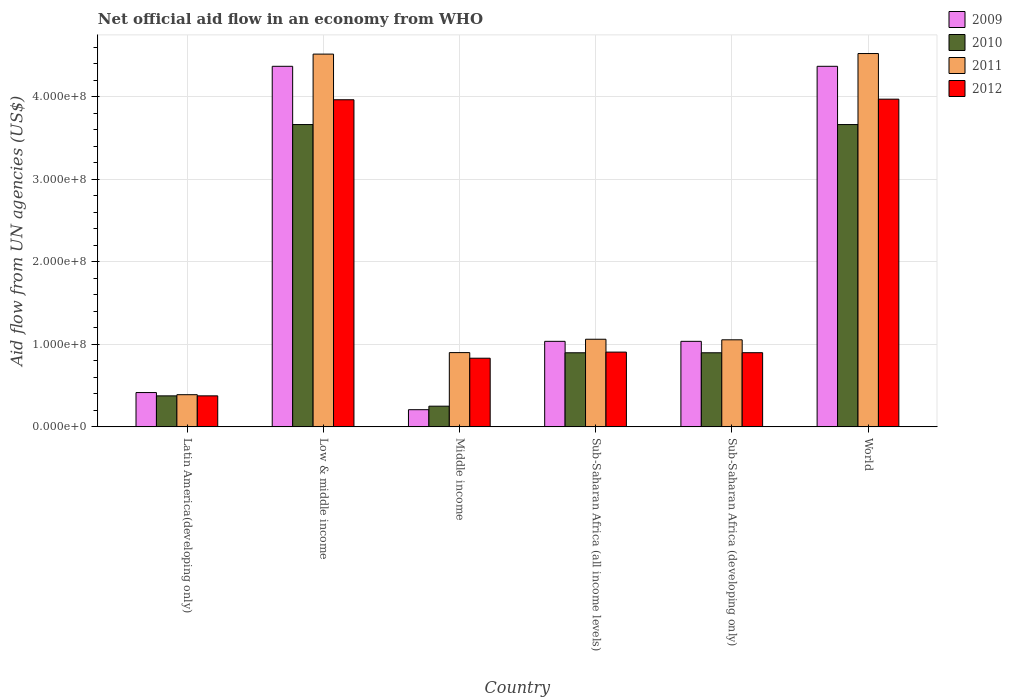Are the number of bars on each tick of the X-axis equal?
Your response must be concise. Yes. How many bars are there on the 5th tick from the left?
Keep it short and to the point. 4. What is the label of the 1st group of bars from the left?
Provide a succinct answer. Latin America(developing only). In how many cases, is the number of bars for a given country not equal to the number of legend labels?
Offer a terse response. 0. What is the net official aid flow in 2010 in Sub-Saharan Africa (all income levels)?
Your answer should be compact. 8.98e+07. Across all countries, what is the maximum net official aid flow in 2012?
Make the answer very short. 3.97e+08. Across all countries, what is the minimum net official aid flow in 2010?
Offer a terse response. 2.51e+07. In which country was the net official aid flow in 2012 minimum?
Your answer should be compact. Latin America(developing only). What is the total net official aid flow in 2009 in the graph?
Provide a short and direct response. 1.14e+09. What is the difference between the net official aid flow in 2009 in Latin America(developing only) and that in Middle income?
Provide a succinct answer. 2.08e+07. What is the difference between the net official aid flow in 2012 in Low & middle income and the net official aid flow in 2010 in World?
Give a very brief answer. 3.00e+07. What is the average net official aid flow in 2010 per country?
Offer a very short reply. 1.62e+08. What is the difference between the net official aid flow of/in 2011 and net official aid flow of/in 2012 in Middle income?
Provide a short and direct response. 6.80e+06. In how many countries, is the net official aid flow in 2011 greater than 400000000 US$?
Offer a very short reply. 2. What is the ratio of the net official aid flow in 2012 in Latin America(developing only) to that in Sub-Saharan Africa (all income levels)?
Provide a succinct answer. 0.41. Is the net official aid flow in 2009 in Sub-Saharan Africa (developing only) less than that in World?
Make the answer very short. Yes. Is the difference between the net official aid flow in 2011 in Sub-Saharan Africa (all income levels) and World greater than the difference between the net official aid flow in 2012 in Sub-Saharan Africa (all income levels) and World?
Your answer should be compact. No. What is the difference between the highest and the second highest net official aid flow in 2012?
Make the answer very short. 3.06e+08. What is the difference between the highest and the lowest net official aid flow in 2010?
Ensure brevity in your answer.  3.41e+08. In how many countries, is the net official aid flow in 2012 greater than the average net official aid flow in 2012 taken over all countries?
Keep it short and to the point. 2. Is it the case that in every country, the sum of the net official aid flow in 2010 and net official aid flow in 2009 is greater than the sum of net official aid flow in 2011 and net official aid flow in 2012?
Your answer should be compact. No. Is it the case that in every country, the sum of the net official aid flow in 2011 and net official aid flow in 2012 is greater than the net official aid flow in 2009?
Offer a terse response. Yes. How many bars are there?
Provide a succinct answer. 24. Are all the bars in the graph horizontal?
Offer a very short reply. No. How many countries are there in the graph?
Provide a succinct answer. 6. Does the graph contain grids?
Give a very brief answer. Yes. How many legend labels are there?
Your answer should be compact. 4. What is the title of the graph?
Keep it short and to the point. Net official aid flow in an economy from WHO. Does "1974" appear as one of the legend labels in the graph?
Your answer should be very brief. No. What is the label or title of the Y-axis?
Make the answer very short. Aid flow from UN agencies (US$). What is the Aid flow from UN agencies (US$) in 2009 in Latin America(developing only)?
Make the answer very short. 4.16e+07. What is the Aid flow from UN agencies (US$) in 2010 in Latin America(developing only)?
Offer a terse response. 3.76e+07. What is the Aid flow from UN agencies (US$) of 2011 in Latin America(developing only)?
Offer a terse response. 3.90e+07. What is the Aid flow from UN agencies (US$) of 2012 in Latin America(developing only)?
Offer a very short reply. 3.76e+07. What is the Aid flow from UN agencies (US$) in 2009 in Low & middle income?
Your response must be concise. 4.37e+08. What is the Aid flow from UN agencies (US$) in 2010 in Low & middle income?
Ensure brevity in your answer.  3.66e+08. What is the Aid flow from UN agencies (US$) of 2011 in Low & middle income?
Offer a terse response. 4.52e+08. What is the Aid flow from UN agencies (US$) of 2012 in Low & middle income?
Offer a very short reply. 3.96e+08. What is the Aid flow from UN agencies (US$) in 2009 in Middle income?
Make the answer very short. 2.08e+07. What is the Aid flow from UN agencies (US$) of 2010 in Middle income?
Keep it short and to the point. 2.51e+07. What is the Aid flow from UN agencies (US$) of 2011 in Middle income?
Your answer should be very brief. 9.00e+07. What is the Aid flow from UN agencies (US$) of 2012 in Middle income?
Provide a short and direct response. 8.32e+07. What is the Aid flow from UN agencies (US$) of 2009 in Sub-Saharan Africa (all income levels)?
Offer a terse response. 1.04e+08. What is the Aid flow from UN agencies (US$) of 2010 in Sub-Saharan Africa (all income levels)?
Your answer should be compact. 8.98e+07. What is the Aid flow from UN agencies (US$) in 2011 in Sub-Saharan Africa (all income levels)?
Give a very brief answer. 1.06e+08. What is the Aid flow from UN agencies (US$) of 2012 in Sub-Saharan Africa (all income levels)?
Provide a succinct answer. 9.06e+07. What is the Aid flow from UN agencies (US$) in 2009 in Sub-Saharan Africa (developing only)?
Your response must be concise. 1.04e+08. What is the Aid flow from UN agencies (US$) of 2010 in Sub-Saharan Africa (developing only)?
Ensure brevity in your answer.  8.98e+07. What is the Aid flow from UN agencies (US$) in 2011 in Sub-Saharan Africa (developing only)?
Your answer should be compact. 1.05e+08. What is the Aid flow from UN agencies (US$) of 2012 in Sub-Saharan Africa (developing only)?
Your answer should be compact. 8.98e+07. What is the Aid flow from UN agencies (US$) of 2009 in World?
Offer a terse response. 4.37e+08. What is the Aid flow from UN agencies (US$) of 2010 in World?
Offer a terse response. 3.66e+08. What is the Aid flow from UN agencies (US$) in 2011 in World?
Your answer should be compact. 4.52e+08. What is the Aid flow from UN agencies (US$) in 2012 in World?
Keep it short and to the point. 3.97e+08. Across all countries, what is the maximum Aid flow from UN agencies (US$) in 2009?
Make the answer very short. 4.37e+08. Across all countries, what is the maximum Aid flow from UN agencies (US$) in 2010?
Keep it short and to the point. 3.66e+08. Across all countries, what is the maximum Aid flow from UN agencies (US$) of 2011?
Give a very brief answer. 4.52e+08. Across all countries, what is the maximum Aid flow from UN agencies (US$) in 2012?
Make the answer very short. 3.97e+08. Across all countries, what is the minimum Aid flow from UN agencies (US$) in 2009?
Give a very brief answer. 2.08e+07. Across all countries, what is the minimum Aid flow from UN agencies (US$) of 2010?
Your answer should be very brief. 2.51e+07. Across all countries, what is the minimum Aid flow from UN agencies (US$) in 2011?
Your response must be concise. 3.90e+07. Across all countries, what is the minimum Aid flow from UN agencies (US$) in 2012?
Make the answer very short. 3.76e+07. What is the total Aid flow from UN agencies (US$) of 2009 in the graph?
Give a very brief answer. 1.14e+09. What is the total Aid flow from UN agencies (US$) of 2010 in the graph?
Make the answer very short. 9.75e+08. What is the total Aid flow from UN agencies (US$) of 2011 in the graph?
Your answer should be very brief. 1.24e+09. What is the total Aid flow from UN agencies (US$) in 2012 in the graph?
Provide a short and direct response. 1.09e+09. What is the difference between the Aid flow from UN agencies (US$) in 2009 in Latin America(developing only) and that in Low & middle income?
Provide a short and direct response. -3.95e+08. What is the difference between the Aid flow from UN agencies (US$) of 2010 in Latin America(developing only) and that in Low & middle income?
Your response must be concise. -3.29e+08. What is the difference between the Aid flow from UN agencies (US$) of 2011 in Latin America(developing only) and that in Low & middle income?
Ensure brevity in your answer.  -4.13e+08. What is the difference between the Aid flow from UN agencies (US$) in 2012 in Latin America(developing only) and that in Low & middle income?
Your response must be concise. -3.59e+08. What is the difference between the Aid flow from UN agencies (US$) of 2009 in Latin America(developing only) and that in Middle income?
Give a very brief answer. 2.08e+07. What is the difference between the Aid flow from UN agencies (US$) of 2010 in Latin America(developing only) and that in Middle income?
Give a very brief answer. 1.25e+07. What is the difference between the Aid flow from UN agencies (US$) in 2011 in Latin America(developing only) and that in Middle income?
Your response must be concise. -5.10e+07. What is the difference between the Aid flow from UN agencies (US$) in 2012 in Latin America(developing only) and that in Middle income?
Keep it short and to the point. -4.56e+07. What is the difference between the Aid flow from UN agencies (US$) of 2009 in Latin America(developing only) and that in Sub-Saharan Africa (all income levels)?
Your answer should be very brief. -6.20e+07. What is the difference between the Aid flow from UN agencies (US$) of 2010 in Latin America(developing only) and that in Sub-Saharan Africa (all income levels)?
Provide a short and direct response. -5.22e+07. What is the difference between the Aid flow from UN agencies (US$) of 2011 in Latin America(developing only) and that in Sub-Saharan Africa (all income levels)?
Your response must be concise. -6.72e+07. What is the difference between the Aid flow from UN agencies (US$) of 2012 in Latin America(developing only) and that in Sub-Saharan Africa (all income levels)?
Offer a terse response. -5.30e+07. What is the difference between the Aid flow from UN agencies (US$) in 2009 in Latin America(developing only) and that in Sub-Saharan Africa (developing only)?
Give a very brief answer. -6.20e+07. What is the difference between the Aid flow from UN agencies (US$) in 2010 in Latin America(developing only) and that in Sub-Saharan Africa (developing only)?
Ensure brevity in your answer.  -5.22e+07. What is the difference between the Aid flow from UN agencies (US$) in 2011 in Latin America(developing only) and that in Sub-Saharan Africa (developing only)?
Your answer should be very brief. -6.65e+07. What is the difference between the Aid flow from UN agencies (US$) of 2012 in Latin America(developing only) and that in Sub-Saharan Africa (developing only)?
Keep it short and to the point. -5.23e+07. What is the difference between the Aid flow from UN agencies (US$) in 2009 in Latin America(developing only) and that in World?
Offer a terse response. -3.95e+08. What is the difference between the Aid flow from UN agencies (US$) of 2010 in Latin America(developing only) and that in World?
Offer a very short reply. -3.29e+08. What is the difference between the Aid flow from UN agencies (US$) of 2011 in Latin America(developing only) and that in World?
Your answer should be compact. -4.13e+08. What is the difference between the Aid flow from UN agencies (US$) in 2012 in Latin America(developing only) and that in World?
Offer a terse response. -3.59e+08. What is the difference between the Aid flow from UN agencies (US$) of 2009 in Low & middle income and that in Middle income?
Give a very brief answer. 4.16e+08. What is the difference between the Aid flow from UN agencies (US$) of 2010 in Low & middle income and that in Middle income?
Give a very brief answer. 3.41e+08. What is the difference between the Aid flow from UN agencies (US$) of 2011 in Low & middle income and that in Middle income?
Your response must be concise. 3.62e+08. What is the difference between the Aid flow from UN agencies (US$) of 2012 in Low & middle income and that in Middle income?
Your answer should be compact. 3.13e+08. What is the difference between the Aid flow from UN agencies (US$) of 2009 in Low & middle income and that in Sub-Saharan Africa (all income levels)?
Offer a very short reply. 3.33e+08. What is the difference between the Aid flow from UN agencies (US$) of 2010 in Low & middle income and that in Sub-Saharan Africa (all income levels)?
Your response must be concise. 2.76e+08. What is the difference between the Aid flow from UN agencies (US$) in 2011 in Low & middle income and that in Sub-Saharan Africa (all income levels)?
Provide a succinct answer. 3.45e+08. What is the difference between the Aid flow from UN agencies (US$) in 2012 in Low & middle income and that in Sub-Saharan Africa (all income levels)?
Your answer should be compact. 3.06e+08. What is the difference between the Aid flow from UN agencies (US$) in 2009 in Low & middle income and that in Sub-Saharan Africa (developing only)?
Give a very brief answer. 3.33e+08. What is the difference between the Aid flow from UN agencies (US$) of 2010 in Low & middle income and that in Sub-Saharan Africa (developing only)?
Offer a very short reply. 2.76e+08. What is the difference between the Aid flow from UN agencies (US$) in 2011 in Low & middle income and that in Sub-Saharan Africa (developing only)?
Ensure brevity in your answer.  3.46e+08. What is the difference between the Aid flow from UN agencies (US$) of 2012 in Low & middle income and that in Sub-Saharan Africa (developing only)?
Your answer should be compact. 3.06e+08. What is the difference between the Aid flow from UN agencies (US$) of 2009 in Low & middle income and that in World?
Offer a terse response. 0. What is the difference between the Aid flow from UN agencies (US$) in 2010 in Low & middle income and that in World?
Ensure brevity in your answer.  0. What is the difference between the Aid flow from UN agencies (US$) of 2011 in Low & middle income and that in World?
Give a very brief answer. -6.70e+05. What is the difference between the Aid flow from UN agencies (US$) of 2012 in Low & middle income and that in World?
Give a very brief answer. -7.20e+05. What is the difference between the Aid flow from UN agencies (US$) of 2009 in Middle income and that in Sub-Saharan Africa (all income levels)?
Your answer should be very brief. -8.28e+07. What is the difference between the Aid flow from UN agencies (US$) in 2010 in Middle income and that in Sub-Saharan Africa (all income levels)?
Give a very brief answer. -6.47e+07. What is the difference between the Aid flow from UN agencies (US$) of 2011 in Middle income and that in Sub-Saharan Africa (all income levels)?
Offer a very short reply. -1.62e+07. What is the difference between the Aid flow from UN agencies (US$) in 2012 in Middle income and that in Sub-Saharan Africa (all income levels)?
Make the answer very short. -7.39e+06. What is the difference between the Aid flow from UN agencies (US$) of 2009 in Middle income and that in Sub-Saharan Africa (developing only)?
Give a very brief answer. -8.28e+07. What is the difference between the Aid flow from UN agencies (US$) of 2010 in Middle income and that in Sub-Saharan Africa (developing only)?
Your answer should be very brief. -6.47e+07. What is the difference between the Aid flow from UN agencies (US$) in 2011 in Middle income and that in Sub-Saharan Africa (developing only)?
Provide a succinct answer. -1.55e+07. What is the difference between the Aid flow from UN agencies (US$) in 2012 in Middle income and that in Sub-Saharan Africa (developing only)?
Make the answer very short. -6.67e+06. What is the difference between the Aid flow from UN agencies (US$) in 2009 in Middle income and that in World?
Offer a very short reply. -4.16e+08. What is the difference between the Aid flow from UN agencies (US$) of 2010 in Middle income and that in World?
Your answer should be compact. -3.41e+08. What is the difference between the Aid flow from UN agencies (US$) of 2011 in Middle income and that in World?
Provide a short and direct response. -3.62e+08. What is the difference between the Aid flow from UN agencies (US$) of 2012 in Middle income and that in World?
Give a very brief answer. -3.14e+08. What is the difference between the Aid flow from UN agencies (US$) of 2009 in Sub-Saharan Africa (all income levels) and that in Sub-Saharan Africa (developing only)?
Keep it short and to the point. 0. What is the difference between the Aid flow from UN agencies (US$) in 2010 in Sub-Saharan Africa (all income levels) and that in Sub-Saharan Africa (developing only)?
Make the answer very short. 0. What is the difference between the Aid flow from UN agencies (US$) in 2011 in Sub-Saharan Africa (all income levels) and that in Sub-Saharan Africa (developing only)?
Give a very brief answer. 6.70e+05. What is the difference between the Aid flow from UN agencies (US$) in 2012 in Sub-Saharan Africa (all income levels) and that in Sub-Saharan Africa (developing only)?
Offer a very short reply. 7.20e+05. What is the difference between the Aid flow from UN agencies (US$) in 2009 in Sub-Saharan Africa (all income levels) and that in World?
Provide a short and direct response. -3.33e+08. What is the difference between the Aid flow from UN agencies (US$) of 2010 in Sub-Saharan Africa (all income levels) and that in World?
Your response must be concise. -2.76e+08. What is the difference between the Aid flow from UN agencies (US$) of 2011 in Sub-Saharan Africa (all income levels) and that in World?
Ensure brevity in your answer.  -3.46e+08. What is the difference between the Aid flow from UN agencies (US$) in 2012 in Sub-Saharan Africa (all income levels) and that in World?
Provide a succinct answer. -3.06e+08. What is the difference between the Aid flow from UN agencies (US$) of 2009 in Sub-Saharan Africa (developing only) and that in World?
Your answer should be compact. -3.33e+08. What is the difference between the Aid flow from UN agencies (US$) in 2010 in Sub-Saharan Africa (developing only) and that in World?
Ensure brevity in your answer.  -2.76e+08. What is the difference between the Aid flow from UN agencies (US$) in 2011 in Sub-Saharan Africa (developing only) and that in World?
Your answer should be very brief. -3.47e+08. What is the difference between the Aid flow from UN agencies (US$) in 2012 in Sub-Saharan Africa (developing only) and that in World?
Offer a very short reply. -3.07e+08. What is the difference between the Aid flow from UN agencies (US$) of 2009 in Latin America(developing only) and the Aid flow from UN agencies (US$) of 2010 in Low & middle income?
Provide a succinct answer. -3.25e+08. What is the difference between the Aid flow from UN agencies (US$) in 2009 in Latin America(developing only) and the Aid flow from UN agencies (US$) in 2011 in Low & middle income?
Ensure brevity in your answer.  -4.10e+08. What is the difference between the Aid flow from UN agencies (US$) in 2009 in Latin America(developing only) and the Aid flow from UN agencies (US$) in 2012 in Low & middle income?
Provide a succinct answer. -3.55e+08. What is the difference between the Aid flow from UN agencies (US$) of 2010 in Latin America(developing only) and the Aid flow from UN agencies (US$) of 2011 in Low & middle income?
Offer a terse response. -4.14e+08. What is the difference between the Aid flow from UN agencies (US$) in 2010 in Latin America(developing only) and the Aid flow from UN agencies (US$) in 2012 in Low & middle income?
Your answer should be compact. -3.59e+08. What is the difference between the Aid flow from UN agencies (US$) in 2011 in Latin America(developing only) and the Aid flow from UN agencies (US$) in 2012 in Low & middle income?
Your answer should be very brief. -3.57e+08. What is the difference between the Aid flow from UN agencies (US$) in 2009 in Latin America(developing only) and the Aid flow from UN agencies (US$) in 2010 in Middle income?
Give a very brief answer. 1.65e+07. What is the difference between the Aid flow from UN agencies (US$) in 2009 in Latin America(developing only) and the Aid flow from UN agencies (US$) in 2011 in Middle income?
Give a very brief answer. -4.84e+07. What is the difference between the Aid flow from UN agencies (US$) in 2009 in Latin America(developing only) and the Aid flow from UN agencies (US$) in 2012 in Middle income?
Make the answer very short. -4.16e+07. What is the difference between the Aid flow from UN agencies (US$) of 2010 in Latin America(developing only) and the Aid flow from UN agencies (US$) of 2011 in Middle income?
Your answer should be compact. -5.24e+07. What is the difference between the Aid flow from UN agencies (US$) of 2010 in Latin America(developing only) and the Aid flow from UN agencies (US$) of 2012 in Middle income?
Offer a very short reply. -4.56e+07. What is the difference between the Aid flow from UN agencies (US$) of 2011 in Latin America(developing only) and the Aid flow from UN agencies (US$) of 2012 in Middle income?
Your answer should be compact. -4.42e+07. What is the difference between the Aid flow from UN agencies (US$) in 2009 in Latin America(developing only) and the Aid flow from UN agencies (US$) in 2010 in Sub-Saharan Africa (all income levels)?
Keep it short and to the point. -4.82e+07. What is the difference between the Aid flow from UN agencies (US$) in 2009 in Latin America(developing only) and the Aid flow from UN agencies (US$) in 2011 in Sub-Saharan Africa (all income levels)?
Offer a very short reply. -6.46e+07. What is the difference between the Aid flow from UN agencies (US$) in 2009 in Latin America(developing only) and the Aid flow from UN agencies (US$) in 2012 in Sub-Saharan Africa (all income levels)?
Your response must be concise. -4.90e+07. What is the difference between the Aid flow from UN agencies (US$) in 2010 in Latin America(developing only) and the Aid flow from UN agencies (US$) in 2011 in Sub-Saharan Africa (all income levels)?
Your answer should be very brief. -6.86e+07. What is the difference between the Aid flow from UN agencies (US$) in 2010 in Latin America(developing only) and the Aid flow from UN agencies (US$) in 2012 in Sub-Saharan Africa (all income levels)?
Your response must be concise. -5.30e+07. What is the difference between the Aid flow from UN agencies (US$) of 2011 in Latin America(developing only) and the Aid flow from UN agencies (US$) of 2012 in Sub-Saharan Africa (all income levels)?
Your response must be concise. -5.16e+07. What is the difference between the Aid flow from UN agencies (US$) of 2009 in Latin America(developing only) and the Aid flow from UN agencies (US$) of 2010 in Sub-Saharan Africa (developing only)?
Provide a succinct answer. -4.82e+07. What is the difference between the Aid flow from UN agencies (US$) of 2009 in Latin America(developing only) and the Aid flow from UN agencies (US$) of 2011 in Sub-Saharan Africa (developing only)?
Ensure brevity in your answer.  -6.39e+07. What is the difference between the Aid flow from UN agencies (US$) of 2009 in Latin America(developing only) and the Aid flow from UN agencies (US$) of 2012 in Sub-Saharan Africa (developing only)?
Ensure brevity in your answer.  -4.83e+07. What is the difference between the Aid flow from UN agencies (US$) of 2010 in Latin America(developing only) and the Aid flow from UN agencies (US$) of 2011 in Sub-Saharan Africa (developing only)?
Your response must be concise. -6.79e+07. What is the difference between the Aid flow from UN agencies (US$) in 2010 in Latin America(developing only) and the Aid flow from UN agencies (US$) in 2012 in Sub-Saharan Africa (developing only)?
Your answer should be compact. -5.23e+07. What is the difference between the Aid flow from UN agencies (US$) in 2011 in Latin America(developing only) and the Aid flow from UN agencies (US$) in 2012 in Sub-Saharan Africa (developing only)?
Keep it short and to the point. -5.09e+07. What is the difference between the Aid flow from UN agencies (US$) of 2009 in Latin America(developing only) and the Aid flow from UN agencies (US$) of 2010 in World?
Give a very brief answer. -3.25e+08. What is the difference between the Aid flow from UN agencies (US$) in 2009 in Latin America(developing only) and the Aid flow from UN agencies (US$) in 2011 in World?
Make the answer very short. -4.11e+08. What is the difference between the Aid flow from UN agencies (US$) of 2009 in Latin America(developing only) and the Aid flow from UN agencies (US$) of 2012 in World?
Provide a short and direct response. -3.55e+08. What is the difference between the Aid flow from UN agencies (US$) of 2010 in Latin America(developing only) and the Aid flow from UN agencies (US$) of 2011 in World?
Ensure brevity in your answer.  -4.15e+08. What is the difference between the Aid flow from UN agencies (US$) in 2010 in Latin America(developing only) and the Aid flow from UN agencies (US$) in 2012 in World?
Provide a succinct answer. -3.59e+08. What is the difference between the Aid flow from UN agencies (US$) in 2011 in Latin America(developing only) and the Aid flow from UN agencies (US$) in 2012 in World?
Your response must be concise. -3.58e+08. What is the difference between the Aid flow from UN agencies (US$) of 2009 in Low & middle income and the Aid flow from UN agencies (US$) of 2010 in Middle income?
Provide a short and direct response. 4.12e+08. What is the difference between the Aid flow from UN agencies (US$) in 2009 in Low & middle income and the Aid flow from UN agencies (US$) in 2011 in Middle income?
Make the answer very short. 3.47e+08. What is the difference between the Aid flow from UN agencies (US$) of 2009 in Low & middle income and the Aid flow from UN agencies (US$) of 2012 in Middle income?
Give a very brief answer. 3.54e+08. What is the difference between the Aid flow from UN agencies (US$) of 2010 in Low & middle income and the Aid flow from UN agencies (US$) of 2011 in Middle income?
Make the answer very short. 2.76e+08. What is the difference between the Aid flow from UN agencies (US$) of 2010 in Low & middle income and the Aid flow from UN agencies (US$) of 2012 in Middle income?
Your answer should be very brief. 2.83e+08. What is the difference between the Aid flow from UN agencies (US$) in 2011 in Low & middle income and the Aid flow from UN agencies (US$) in 2012 in Middle income?
Your response must be concise. 3.68e+08. What is the difference between the Aid flow from UN agencies (US$) in 2009 in Low & middle income and the Aid flow from UN agencies (US$) in 2010 in Sub-Saharan Africa (all income levels)?
Your answer should be very brief. 3.47e+08. What is the difference between the Aid flow from UN agencies (US$) in 2009 in Low & middle income and the Aid flow from UN agencies (US$) in 2011 in Sub-Saharan Africa (all income levels)?
Make the answer very short. 3.31e+08. What is the difference between the Aid flow from UN agencies (US$) of 2009 in Low & middle income and the Aid flow from UN agencies (US$) of 2012 in Sub-Saharan Africa (all income levels)?
Provide a succinct answer. 3.46e+08. What is the difference between the Aid flow from UN agencies (US$) of 2010 in Low & middle income and the Aid flow from UN agencies (US$) of 2011 in Sub-Saharan Africa (all income levels)?
Provide a short and direct response. 2.60e+08. What is the difference between the Aid flow from UN agencies (US$) in 2010 in Low & middle income and the Aid flow from UN agencies (US$) in 2012 in Sub-Saharan Africa (all income levels)?
Offer a terse response. 2.76e+08. What is the difference between the Aid flow from UN agencies (US$) of 2011 in Low & middle income and the Aid flow from UN agencies (US$) of 2012 in Sub-Saharan Africa (all income levels)?
Provide a succinct answer. 3.61e+08. What is the difference between the Aid flow from UN agencies (US$) in 2009 in Low & middle income and the Aid flow from UN agencies (US$) in 2010 in Sub-Saharan Africa (developing only)?
Keep it short and to the point. 3.47e+08. What is the difference between the Aid flow from UN agencies (US$) in 2009 in Low & middle income and the Aid flow from UN agencies (US$) in 2011 in Sub-Saharan Africa (developing only)?
Your response must be concise. 3.31e+08. What is the difference between the Aid flow from UN agencies (US$) in 2009 in Low & middle income and the Aid flow from UN agencies (US$) in 2012 in Sub-Saharan Africa (developing only)?
Give a very brief answer. 3.47e+08. What is the difference between the Aid flow from UN agencies (US$) in 2010 in Low & middle income and the Aid flow from UN agencies (US$) in 2011 in Sub-Saharan Africa (developing only)?
Your answer should be compact. 2.61e+08. What is the difference between the Aid flow from UN agencies (US$) in 2010 in Low & middle income and the Aid flow from UN agencies (US$) in 2012 in Sub-Saharan Africa (developing only)?
Your answer should be very brief. 2.76e+08. What is the difference between the Aid flow from UN agencies (US$) of 2011 in Low & middle income and the Aid flow from UN agencies (US$) of 2012 in Sub-Saharan Africa (developing only)?
Provide a short and direct response. 3.62e+08. What is the difference between the Aid flow from UN agencies (US$) of 2009 in Low & middle income and the Aid flow from UN agencies (US$) of 2010 in World?
Your answer should be compact. 7.06e+07. What is the difference between the Aid flow from UN agencies (US$) of 2009 in Low & middle income and the Aid flow from UN agencies (US$) of 2011 in World?
Ensure brevity in your answer.  -1.55e+07. What is the difference between the Aid flow from UN agencies (US$) of 2009 in Low & middle income and the Aid flow from UN agencies (US$) of 2012 in World?
Your answer should be very brief. 3.98e+07. What is the difference between the Aid flow from UN agencies (US$) in 2010 in Low & middle income and the Aid flow from UN agencies (US$) in 2011 in World?
Your answer should be compact. -8.60e+07. What is the difference between the Aid flow from UN agencies (US$) in 2010 in Low & middle income and the Aid flow from UN agencies (US$) in 2012 in World?
Offer a terse response. -3.08e+07. What is the difference between the Aid flow from UN agencies (US$) of 2011 in Low & middle income and the Aid flow from UN agencies (US$) of 2012 in World?
Provide a succinct answer. 5.46e+07. What is the difference between the Aid flow from UN agencies (US$) of 2009 in Middle income and the Aid flow from UN agencies (US$) of 2010 in Sub-Saharan Africa (all income levels)?
Provide a short and direct response. -6.90e+07. What is the difference between the Aid flow from UN agencies (US$) in 2009 in Middle income and the Aid flow from UN agencies (US$) in 2011 in Sub-Saharan Africa (all income levels)?
Make the answer very short. -8.54e+07. What is the difference between the Aid flow from UN agencies (US$) in 2009 in Middle income and the Aid flow from UN agencies (US$) in 2012 in Sub-Saharan Africa (all income levels)?
Provide a short and direct response. -6.98e+07. What is the difference between the Aid flow from UN agencies (US$) of 2010 in Middle income and the Aid flow from UN agencies (US$) of 2011 in Sub-Saharan Africa (all income levels)?
Provide a short and direct response. -8.11e+07. What is the difference between the Aid flow from UN agencies (US$) in 2010 in Middle income and the Aid flow from UN agencies (US$) in 2012 in Sub-Saharan Africa (all income levels)?
Provide a short and direct response. -6.55e+07. What is the difference between the Aid flow from UN agencies (US$) in 2011 in Middle income and the Aid flow from UN agencies (US$) in 2012 in Sub-Saharan Africa (all income levels)?
Offer a very short reply. -5.90e+05. What is the difference between the Aid flow from UN agencies (US$) in 2009 in Middle income and the Aid flow from UN agencies (US$) in 2010 in Sub-Saharan Africa (developing only)?
Make the answer very short. -6.90e+07. What is the difference between the Aid flow from UN agencies (US$) of 2009 in Middle income and the Aid flow from UN agencies (US$) of 2011 in Sub-Saharan Africa (developing only)?
Your response must be concise. -8.47e+07. What is the difference between the Aid flow from UN agencies (US$) of 2009 in Middle income and the Aid flow from UN agencies (US$) of 2012 in Sub-Saharan Africa (developing only)?
Offer a terse response. -6.90e+07. What is the difference between the Aid flow from UN agencies (US$) in 2010 in Middle income and the Aid flow from UN agencies (US$) in 2011 in Sub-Saharan Africa (developing only)?
Your answer should be very brief. -8.04e+07. What is the difference between the Aid flow from UN agencies (US$) in 2010 in Middle income and the Aid flow from UN agencies (US$) in 2012 in Sub-Saharan Africa (developing only)?
Your answer should be very brief. -6.48e+07. What is the difference between the Aid flow from UN agencies (US$) in 2011 in Middle income and the Aid flow from UN agencies (US$) in 2012 in Sub-Saharan Africa (developing only)?
Your response must be concise. 1.30e+05. What is the difference between the Aid flow from UN agencies (US$) in 2009 in Middle income and the Aid flow from UN agencies (US$) in 2010 in World?
Make the answer very short. -3.45e+08. What is the difference between the Aid flow from UN agencies (US$) of 2009 in Middle income and the Aid flow from UN agencies (US$) of 2011 in World?
Keep it short and to the point. -4.31e+08. What is the difference between the Aid flow from UN agencies (US$) of 2009 in Middle income and the Aid flow from UN agencies (US$) of 2012 in World?
Your response must be concise. -3.76e+08. What is the difference between the Aid flow from UN agencies (US$) of 2010 in Middle income and the Aid flow from UN agencies (US$) of 2011 in World?
Keep it short and to the point. -4.27e+08. What is the difference between the Aid flow from UN agencies (US$) in 2010 in Middle income and the Aid flow from UN agencies (US$) in 2012 in World?
Your answer should be compact. -3.72e+08. What is the difference between the Aid flow from UN agencies (US$) in 2011 in Middle income and the Aid flow from UN agencies (US$) in 2012 in World?
Make the answer very short. -3.07e+08. What is the difference between the Aid flow from UN agencies (US$) in 2009 in Sub-Saharan Africa (all income levels) and the Aid flow from UN agencies (US$) in 2010 in Sub-Saharan Africa (developing only)?
Provide a short and direct response. 1.39e+07. What is the difference between the Aid flow from UN agencies (US$) in 2009 in Sub-Saharan Africa (all income levels) and the Aid flow from UN agencies (US$) in 2011 in Sub-Saharan Africa (developing only)?
Ensure brevity in your answer.  -1.86e+06. What is the difference between the Aid flow from UN agencies (US$) of 2009 in Sub-Saharan Africa (all income levels) and the Aid flow from UN agencies (US$) of 2012 in Sub-Saharan Africa (developing only)?
Provide a short and direct response. 1.38e+07. What is the difference between the Aid flow from UN agencies (US$) in 2010 in Sub-Saharan Africa (all income levels) and the Aid flow from UN agencies (US$) in 2011 in Sub-Saharan Africa (developing only)?
Offer a very short reply. -1.57e+07. What is the difference between the Aid flow from UN agencies (US$) of 2011 in Sub-Saharan Africa (all income levels) and the Aid flow from UN agencies (US$) of 2012 in Sub-Saharan Africa (developing only)?
Provide a succinct answer. 1.63e+07. What is the difference between the Aid flow from UN agencies (US$) of 2009 in Sub-Saharan Africa (all income levels) and the Aid flow from UN agencies (US$) of 2010 in World?
Offer a very short reply. -2.63e+08. What is the difference between the Aid flow from UN agencies (US$) in 2009 in Sub-Saharan Africa (all income levels) and the Aid flow from UN agencies (US$) in 2011 in World?
Your answer should be very brief. -3.49e+08. What is the difference between the Aid flow from UN agencies (US$) in 2009 in Sub-Saharan Africa (all income levels) and the Aid flow from UN agencies (US$) in 2012 in World?
Your answer should be very brief. -2.93e+08. What is the difference between the Aid flow from UN agencies (US$) of 2010 in Sub-Saharan Africa (all income levels) and the Aid flow from UN agencies (US$) of 2011 in World?
Offer a terse response. -3.62e+08. What is the difference between the Aid flow from UN agencies (US$) in 2010 in Sub-Saharan Africa (all income levels) and the Aid flow from UN agencies (US$) in 2012 in World?
Ensure brevity in your answer.  -3.07e+08. What is the difference between the Aid flow from UN agencies (US$) in 2011 in Sub-Saharan Africa (all income levels) and the Aid flow from UN agencies (US$) in 2012 in World?
Give a very brief answer. -2.91e+08. What is the difference between the Aid flow from UN agencies (US$) of 2009 in Sub-Saharan Africa (developing only) and the Aid flow from UN agencies (US$) of 2010 in World?
Keep it short and to the point. -2.63e+08. What is the difference between the Aid flow from UN agencies (US$) of 2009 in Sub-Saharan Africa (developing only) and the Aid flow from UN agencies (US$) of 2011 in World?
Provide a succinct answer. -3.49e+08. What is the difference between the Aid flow from UN agencies (US$) of 2009 in Sub-Saharan Africa (developing only) and the Aid flow from UN agencies (US$) of 2012 in World?
Provide a succinct answer. -2.93e+08. What is the difference between the Aid flow from UN agencies (US$) in 2010 in Sub-Saharan Africa (developing only) and the Aid flow from UN agencies (US$) in 2011 in World?
Ensure brevity in your answer.  -3.62e+08. What is the difference between the Aid flow from UN agencies (US$) in 2010 in Sub-Saharan Africa (developing only) and the Aid flow from UN agencies (US$) in 2012 in World?
Make the answer very short. -3.07e+08. What is the difference between the Aid flow from UN agencies (US$) of 2011 in Sub-Saharan Africa (developing only) and the Aid flow from UN agencies (US$) of 2012 in World?
Make the answer very short. -2.92e+08. What is the average Aid flow from UN agencies (US$) of 2009 per country?
Your answer should be very brief. 1.91e+08. What is the average Aid flow from UN agencies (US$) of 2010 per country?
Make the answer very short. 1.62e+08. What is the average Aid flow from UN agencies (US$) in 2011 per country?
Provide a succinct answer. 2.07e+08. What is the average Aid flow from UN agencies (US$) in 2012 per country?
Keep it short and to the point. 1.82e+08. What is the difference between the Aid flow from UN agencies (US$) of 2009 and Aid flow from UN agencies (US$) of 2010 in Latin America(developing only)?
Ensure brevity in your answer.  4.01e+06. What is the difference between the Aid flow from UN agencies (US$) of 2009 and Aid flow from UN agencies (US$) of 2011 in Latin America(developing only)?
Give a very brief answer. 2.59e+06. What is the difference between the Aid flow from UN agencies (US$) of 2009 and Aid flow from UN agencies (US$) of 2012 in Latin America(developing only)?
Make the answer very short. 3.99e+06. What is the difference between the Aid flow from UN agencies (US$) of 2010 and Aid flow from UN agencies (US$) of 2011 in Latin America(developing only)?
Keep it short and to the point. -1.42e+06. What is the difference between the Aid flow from UN agencies (US$) of 2010 and Aid flow from UN agencies (US$) of 2012 in Latin America(developing only)?
Keep it short and to the point. -2.00e+04. What is the difference between the Aid flow from UN agencies (US$) of 2011 and Aid flow from UN agencies (US$) of 2012 in Latin America(developing only)?
Keep it short and to the point. 1.40e+06. What is the difference between the Aid flow from UN agencies (US$) in 2009 and Aid flow from UN agencies (US$) in 2010 in Low & middle income?
Ensure brevity in your answer.  7.06e+07. What is the difference between the Aid flow from UN agencies (US$) of 2009 and Aid flow from UN agencies (US$) of 2011 in Low & middle income?
Your answer should be very brief. -1.48e+07. What is the difference between the Aid flow from UN agencies (US$) of 2009 and Aid flow from UN agencies (US$) of 2012 in Low & middle income?
Give a very brief answer. 4.05e+07. What is the difference between the Aid flow from UN agencies (US$) of 2010 and Aid flow from UN agencies (US$) of 2011 in Low & middle income?
Ensure brevity in your answer.  -8.54e+07. What is the difference between the Aid flow from UN agencies (US$) of 2010 and Aid flow from UN agencies (US$) of 2012 in Low & middle income?
Offer a terse response. -3.00e+07. What is the difference between the Aid flow from UN agencies (US$) in 2011 and Aid flow from UN agencies (US$) in 2012 in Low & middle income?
Offer a terse response. 5.53e+07. What is the difference between the Aid flow from UN agencies (US$) in 2009 and Aid flow from UN agencies (US$) in 2010 in Middle income?
Provide a short and direct response. -4.27e+06. What is the difference between the Aid flow from UN agencies (US$) in 2009 and Aid flow from UN agencies (US$) in 2011 in Middle income?
Your response must be concise. -6.92e+07. What is the difference between the Aid flow from UN agencies (US$) in 2009 and Aid flow from UN agencies (US$) in 2012 in Middle income?
Provide a succinct answer. -6.24e+07. What is the difference between the Aid flow from UN agencies (US$) of 2010 and Aid flow from UN agencies (US$) of 2011 in Middle income?
Provide a short and direct response. -6.49e+07. What is the difference between the Aid flow from UN agencies (US$) in 2010 and Aid flow from UN agencies (US$) in 2012 in Middle income?
Your response must be concise. -5.81e+07. What is the difference between the Aid flow from UN agencies (US$) in 2011 and Aid flow from UN agencies (US$) in 2012 in Middle income?
Your answer should be very brief. 6.80e+06. What is the difference between the Aid flow from UN agencies (US$) in 2009 and Aid flow from UN agencies (US$) in 2010 in Sub-Saharan Africa (all income levels)?
Your answer should be compact. 1.39e+07. What is the difference between the Aid flow from UN agencies (US$) of 2009 and Aid flow from UN agencies (US$) of 2011 in Sub-Saharan Africa (all income levels)?
Provide a succinct answer. -2.53e+06. What is the difference between the Aid flow from UN agencies (US$) of 2009 and Aid flow from UN agencies (US$) of 2012 in Sub-Saharan Africa (all income levels)?
Keep it short and to the point. 1.30e+07. What is the difference between the Aid flow from UN agencies (US$) of 2010 and Aid flow from UN agencies (US$) of 2011 in Sub-Saharan Africa (all income levels)?
Make the answer very short. -1.64e+07. What is the difference between the Aid flow from UN agencies (US$) of 2010 and Aid flow from UN agencies (US$) of 2012 in Sub-Saharan Africa (all income levels)?
Offer a very short reply. -8.10e+05. What is the difference between the Aid flow from UN agencies (US$) in 2011 and Aid flow from UN agencies (US$) in 2012 in Sub-Saharan Africa (all income levels)?
Your answer should be compact. 1.56e+07. What is the difference between the Aid flow from UN agencies (US$) of 2009 and Aid flow from UN agencies (US$) of 2010 in Sub-Saharan Africa (developing only)?
Offer a very short reply. 1.39e+07. What is the difference between the Aid flow from UN agencies (US$) in 2009 and Aid flow from UN agencies (US$) in 2011 in Sub-Saharan Africa (developing only)?
Offer a terse response. -1.86e+06. What is the difference between the Aid flow from UN agencies (US$) of 2009 and Aid flow from UN agencies (US$) of 2012 in Sub-Saharan Africa (developing only)?
Your answer should be compact. 1.38e+07. What is the difference between the Aid flow from UN agencies (US$) in 2010 and Aid flow from UN agencies (US$) in 2011 in Sub-Saharan Africa (developing only)?
Your answer should be compact. -1.57e+07. What is the difference between the Aid flow from UN agencies (US$) of 2011 and Aid flow from UN agencies (US$) of 2012 in Sub-Saharan Africa (developing only)?
Provide a succinct answer. 1.56e+07. What is the difference between the Aid flow from UN agencies (US$) of 2009 and Aid flow from UN agencies (US$) of 2010 in World?
Make the answer very short. 7.06e+07. What is the difference between the Aid flow from UN agencies (US$) of 2009 and Aid flow from UN agencies (US$) of 2011 in World?
Keep it short and to the point. -1.55e+07. What is the difference between the Aid flow from UN agencies (US$) of 2009 and Aid flow from UN agencies (US$) of 2012 in World?
Your answer should be very brief. 3.98e+07. What is the difference between the Aid flow from UN agencies (US$) in 2010 and Aid flow from UN agencies (US$) in 2011 in World?
Your response must be concise. -8.60e+07. What is the difference between the Aid flow from UN agencies (US$) in 2010 and Aid flow from UN agencies (US$) in 2012 in World?
Offer a very short reply. -3.08e+07. What is the difference between the Aid flow from UN agencies (US$) of 2011 and Aid flow from UN agencies (US$) of 2012 in World?
Your answer should be compact. 5.53e+07. What is the ratio of the Aid flow from UN agencies (US$) in 2009 in Latin America(developing only) to that in Low & middle income?
Provide a short and direct response. 0.1. What is the ratio of the Aid flow from UN agencies (US$) in 2010 in Latin America(developing only) to that in Low & middle income?
Keep it short and to the point. 0.1. What is the ratio of the Aid flow from UN agencies (US$) in 2011 in Latin America(developing only) to that in Low & middle income?
Ensure brevity in your answer.  0.09. What is the ratio of the Aid flow from UN agencies (US$) in 2012 in Latin America(developing only) to that in Low & middle income?
Offer a very short reply. 0.09. What is the ratio of the Aid flow from UN agencies (US$) in 2009 in Latin America(developing only) to that in Middle income?
Your response must be concise. 2. What is the ratio of the Aid flow from UN agencies (US$) in 2010 in Latin America(developing only) to that in Middle income?
Ensure brevity in your answer.  1.5. What is the ratio of the Aid flow from UN agencies (US$) in 2011 in Latin America(developing only) to that in Middle income?
Provide a succinct answer. 0.43. What is the ratio of the Aid flow from UN agencies (US$) in 2012 in Latin America(developing only) to that in Middle income?
Your answer should be compact. 0.45. What is the ratio of the Aid flow from UN agencies (US$) of 2009 in Latin America(developing only) to that in Sub-Saharan Africa (all income levels)?
Your answer should be very brief. 0.4. What is the ratio of the Aid flow from UN agencies (US$) in 2010 in Latin America(developing only) to that in Sub-Saharan Africa (all income levels)?
Your response must be concise. 0.42. What is the ratio of the Aid flow from UN agencies (US$) of 2011 in Latin America(developing only) to that in Sub-Saharan Africa (all income levels)?
Your answer should be very brief. 0.37. What is the ratio of the Aid flow from UN agencies (US$) in 2012 in Latin America(developing only) to that in Sub-Saharan Africa (all income levels)?
Your answer should be very brief. 0.41. What is the ratio of the Aid flow from UN agencies (US$) in 2009 in Latin America(developing only) to that in Sub-Saharan Africa (developing only)?
Your answer should be very brief. 0.4. What is the ratio of the Aid flow from UN agencies (US$) in 2010 in Latin America(developing only) to that in Sub-Saharan Africa (developing only)?
Ensure brevity in your answer.  0.42. What is the ratio of the Aid flow from UN agencies (US$) of 2011 in Latin America(developing only) to that in Sub-Saharan Africa (developing only)?
Your response must be concise. 0.37. What is the ratio of the Aid flow from UN agencies (US$) of 2012 in Latin America(developing only) to that in Sub-Saharan Africa (developing only)?
Your answer should be compact. 0.42. What is the ratio of the Aid flow from UN agencies (US$) of 2009 in Latin America(developing only) to that in World?
Offer a terse response. 0.1. What is the ratio of the Aid flow from UN agencies (US$) in 2010 in Latin America(developing only) to that in World?
Offer a very short reply. 0.1. What is the ratio of the Aid flow from UN agencies (US$) in 2011 in Latin America(developing only) to that in World?
Keep it short and to the point. 0.09. What is the ratio of the Aid flow from UN agencies (US$) in 2012 in Latin America(developing only) to that in World?
Give a very brief answer. 0.09. What is the ratio of the Aid flow from UN agencies (US$) in 2009 in Low & middle income to that in Middle income?
Your answer should be very brief. 21. What is the ratio of the Aid flow from UN agencies (US$) of 2010 in Low & middle income to that in Middle income?
Give a very brief answer. 14.61. What is the ratio of the Aid flow from UN agencies (US$) in 2011 in Low & middle income to that in Middle income?
Offer a terse response. 5.02. What is the ratio of the Aid flow from UN agencies (US$) of 2012 in Low & middle income to that in Middle income?
Make the answer very short. 4.76. What is the ratio of the Aid flow from UN agencies (US$) of 2009 in Low & middle income to that in Sub-Saharan Africa (all income levels)?
Your answer should be very brief. 4.22. What is the ratio of the Aid flow from UN agencies (US$) of 2010 in Low & middle income to that in Sub-Saharan Africa (all income levels)?
Provide a short and direct response. 4.08. What is the ratio of the Aid flow from UN agencies (US$) of 2011 in Low & middle income to that in Sub-Saharan Africa (all income levels)?
Your answer should be compact. 4.25. What is the ratio of the Aid flow from UN agencies (US$) in 2012 in Low & middle income to that in Sub-Saharan Africa (all income levels)?
Offer a very short reply. 4.38. What is the ratio of the Aid flow from UN agencies (US$) in 2009 in Low & middle income to that in Sub-Saharan Africa (developing only)?
Provide a succinct answer. 4.22. What is the ratio of the Aid flow from UN agencies (US$) of 2010 in Low & middle income to that in Sub-Saharan Africa (developing only)?
Make the answer very short. 4.08. What is the ratio of the Aid flow from UN agencies (US$) in 2011 in Low & middle income to that in Sub-Saharan Africa (developing only)?
Provide a short and direct response. 4.28. What is the ratio of the Aid flow from UN agencies (US$) of 2012 in Low & middle income to that in Sub-Saharan Africa (developing only)?
Provide a succinct answer. 4.41. What is the ratio of the Aid flow from UN agencies (US$) of 2009 in Low & middle income to that in World?
Provide a short and direct response. 1. What is the ratio of the Aid flow from UN agencies (US$) of 2010 in Low & middle income to that in World?
Offer a very short reply. 1. What is the ratio of the Aid flow from UN agencies (US$) in 2009 in Middle income to that in Sub-Saharan Africa (all income levels)?
Make the answer very short. 0.2. What is the ratio of the Aid flow from UN agencies (US$) of 2010 in Middle income to that in Sub-Saharan Africa (all income levels)?
Give a very brief answer. 0.28. What is the ratio of the Aid flow from UN agencies (US$) in 2011 in Middle income to that in Sub-Saharan Africa (all income levels)?
Provide a succinct answer. 0.85. What is the ratio of the Aid flow from UN agencies (US$) of 2012 in Middle income to that in Sub-Saharan Africa (all income levels)?
Your answer should be compact. 0.92. What is the ratio of the Aid flow from UN agencies (US$) of 2009 in Middle income to that in Sub-Saharan Africa (developing only)?
Provide a succinct answer. 0.2. What is the ratio of the Aid flow from UN agencies (US$) in 2010 in Middle income to that in Sub-Saharan Africa (developing only)?
Ensure brevity in your answer.  0.28. What is the ratio of the Aid flow from UN agencies (US$) of 2011 in Middle income to that in Sub-Saharan Africa (developing only)?
Provide a succinct answer. 0.85. What is the ratio of the Aid flow from UN agencies (US$) in 2012 in Middle income to that in Sub-Saharan Africa (developing only)?
Make the answer very short. 0.93. What is the ratio of the Aid flow from UN agencies (US$) in 2009 in Middle income to that in World?
Offer a terse response. 0.05. What is the ratio of the Aid flow from UN agencies (US$) in 2010 in Middle income to that in World?
Give a very brief answer. 0.07. What is the ratio of the Aid flow from UN agencies (US$) of 2011 in Middle income to that in World?
Offer a very short reply. 0.2. What is the ratio of the Aid flow from UN agencies (US$) in 2012 in Middle income to that in World?
Provide a succinct answer. 0.21. What is the ratio of the Aid flow from UN agencies (US$) of 2010 in Sub-Saharan Africa (all income levels) to that in Sub-Saharan Africa (developing only)?
Your answer should be compact. 1. What is the ratio of the Aid flow from UN agencies (US$) in 2011 in Sub-Saharan Africa (all income levels) to that in Sub-Saharan Africa (developing only)?
Offer a very short reply. 1.01. What is the ratio of the Aid flow from UN agencies (US$) in 2012 in Sub-Saharan Africa (all income levels) to that in Sub-Saharan Africa (developing only)?
Provide a succinct answer. 1.01. What is the ratio of the Aid flow from UN agencies (US$) in 2009 in Sub-Saharan Africa (all income levels) to that in World?
Your response must be concise. 0.24. What is the ratio of the Aid flow from UN agencies (US$) of 2010 in Sub-Saharan Africa (all income levels) to that in World?
Offer a very short reply. 0.25. What is the ratio of the Aid flow from UN agencies (US$) of 2011 in Sub-Saharan Africa (all income levels) to that in World?
Provide a succinct answer. 0.23. What is the ratio of the Aid flow from UN agencies (US$) of 2012 in Sub-Saharan Africa (all income levels) to that in World?
Your answer should be compact. 0.23. What is the ratio of the Aid flow from UN agencies (US$) of 2009 in Sub-Saharan Africa (developing only) to that in World?
Keep it short and to the point. 0.24. What is the ratio of the Aid flow from UN agencies (US$) of 2010 in Sub-Saharan Africa (developing only) to that in World?
Provide a succinct answer. 0.25. What is the ratio of the Aid flow from UN agencies (US$) in 2011 in Sub-Saharan Africa (developing only) to that in World?
Offer a very short reply. 0.23. What is the ratio of the Aid flow from UN agencies (US$) of 2012 in Sub-Saharan Africa (developing only) to that in World?
Offer a very short reply. 0.23. What is the difference between the highest and the second highest Aid flow from UN agencies (US$) in 2009?
Your response must be concise. 0. What is the difference between the highest and the second highest Aid flow from UN agencies (US$) in 2011?
Provide a succinct answer. 6.70e+05. What is the difference between the highest and the second highest Aid flow from UN agencies (US$) of 2012?
Ensure brevity in your answer.  7.20e+05. What is the difference between the highest and the lowest Aid flow from UN agencies (US$) in 2009?
Provide a succinct answer. 4.16e+08. What is the difference between the highest and the lowest Aid flow from UN agencies (US$) in 2010?
Make the answer very short. 3.41e+08. What is the difference between the highest and the lowest Aid flow from UN agencies (US$) in 2011?
Offer a terse response. 4.13e+08. What is the difference between the highest and the lowest Aid flow from UN agencies (US$) of 2012?
Offer a terse response. 3.59e+08. 